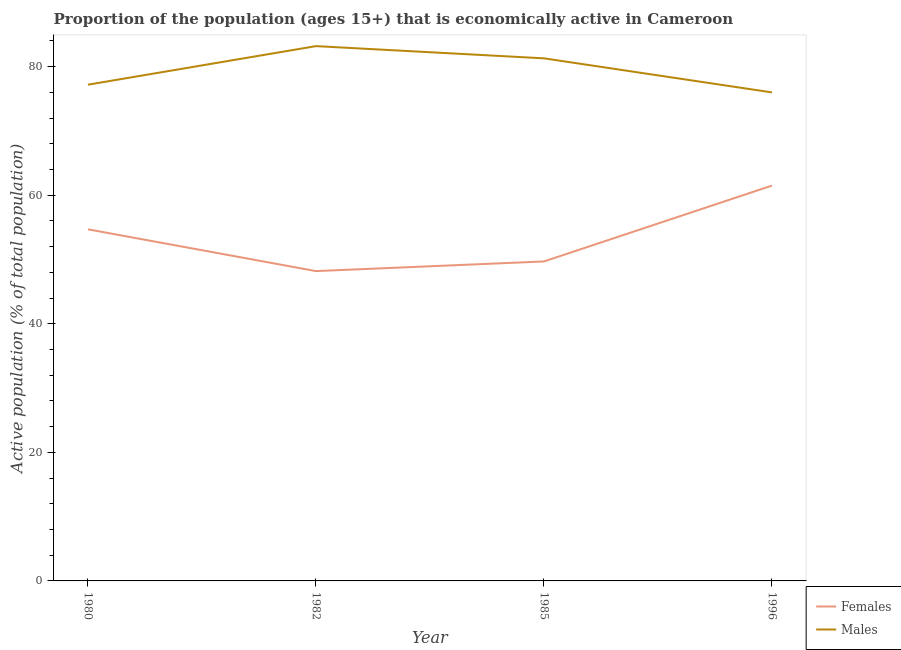Is the number of lines equal to the number of legend labels?
Provide a succinct answer. Yes. What is the percentage of economically active male population in 1985?
Ensure brevity in your answer.  81.3. Across all years, what is the maximum percentage of economically active male population?
Your response must be concise. 83.2. Across all years, what is the minimum percentage of economically active female population?
Make the answer very short. 48.2. In which year was the percentage of economically active female population minimum?
Keep it short and to the point. 1982. What is the total percentage of economically active female population in the graph?
Provide a succinct answer. 214.1. What is the difference between the percentage of economically active male population in 1980 and that in 1985?
Offer a terse response. -4.1. What is the difference between the percentage of economically active male population in 1996 and the percentage of economically active female population in 1982?
Make the answer very short. 27.8. What is the average percentage of economically active male population per year?
Provide a succinct answer. 79.42. In the year 1980, what is the difference between the percentage of economically active male population and percentage of economically active female population?
Provide a succinct answer. 22.5. What is the ratio of the percentage of economically active female population in 1985 to that in 1996?
Keep it short and to the point. 0.81. Is the percentage of economically active female population in 1985 less than that in 1996?
Your response must be concise. Yes. Is the difference between the percentage of economically active female population in 1980 and 1982 greater than the difference between the percentage of economically active male population in 1980 and 1982?
Make the answer very short. Yes. What is the difference between the highest and the second highest percentage of economically active female population?
Offer a terse response. 6.8. What is the difference between the highest and the lowest percentage of economically active female population?
Keep it short and to the point. 13.3. Is the sum of the percentage of economically active male population in 1982 and 1985 greater than the maximum percentage of economically active female population across all years?
Your answer should be compact. Yes. Does the percentage of economically active female population monotonically increase over the years?
Ensure brevity in your answer.  No. Is the percentage of economically active male population strictly less than the percentage of economically active female population over the years?
Provide a succinct answer. No. Does the graph contain any zero values?
Provide a short and direct response. No. How many legend labels are there?
Offer a terse response. 2. How are the legend labels stacked?
Ensure brevity in your answer.  Vertical. What is the title of the graph?
Provide a short and direct response. Proportion of the population (ages 15+) that is economically active in Cameroon. Does "Infant" appear as one of the legend labels in the graph?
Provide a succinct answer. No. What is the label or title of the Y-axis?
Give a very brief answer. Active population (% of total population). What is the Active population (% of total population) in Females in 1980?
Offer a terse response. 54.7. What is the Active population (% of total population) in Males in 1980?
Ensure brevity in your answer.  77.2. What is the Active population (% of total population) of Females in 1982?
Ensure brevity in your answer.  48.2. What is the Active population (% of total population) in Males in 1982?
Make the answer very short. 83.2. What is the Active population (% of total population) of Females in 1985?
Ensure brevity in your answer.  49.7. What is the Active population (% of total population) of Males in 1985?
Your response must be concise. 81.3. What is the Active population (% of total population) of Females in 1996?
Ensure brevity in your answer.  61.5. What is the Active population (% of total population) in Males in 1996?
Your answer should be very brief. 76. Across all years, what is the maximum Active population (% of total population) of Females?
Keep it short and to the point. 61.5. Across all years, what is the maximum Active population (% of total population) of Males?
Keep it short and to the point. 83.2. Across all years, what is the minimum Active population (% of total population) in Females?
Ensure brevity in your answer.  48.2. Across all years, what is the minimum Active population (% of total population) of Males?
Your response must be concise. 76. What is the total Active population (% of total population) of Females in the graph?
Your response must be concise. 214.1. What is the total Active population (% of total population) of Males in the graph?
Your answer should be very brief. 317.7. What is the difference between the Active population (% of total population) in Females in 1980 and that in 1982?
Offer a terse response. 6.5. What is the difference between the Active population (% of total population) of Males in 1980 and that in 1982?
Keep it short and to the point. -6. What is the difference between the Active population (% of total population) of Females in 1980 and that in 1985?
Keep it short and to the point. 5. What is the difference between the Active population (% of total population) of Males in 1980 and that in 1996?
Offer a terse response. 1.2. What is the difference between the Active population (% of total population) of Males in 1982 and that in 1985?
Give a very brief answer. 1.9. What is the difference between the Active population (% of total population) of Males in 1982 and that in 1996?
Make the answer very short. 7.2. What is the difference between the Active population (% of total population) of Females in 1980 and the Active population (% of total population) of Males in 1982?
Your answer should be compact. -28.5. What is the difference between the Active population (% of total population) of Females in 1980 and the Active population (% of total population) of Males in 1985?
Ensure brevity in your answer.  -26.6. What is the difference between the Active population (% of total population) in Females in 1980 and the Active population (% of total population) in Males in 1996?
Provide a succinct answer. -21.3. What is the difference between the Active population (% of total population) of Females in 1982 and the Active population (% of total population) of Males in 1985?
Your answer should be very brief. -33.1. What is the difference between the Active population (% of total population) of Females in 1982 and the Active population (% of total population) of Males in 1996?
Make the answer very short. -27.8. What is the difference between the Active population (% of total population) of Females in 1985 and the Active population (% of total population) of Males in 1996?
Provide a short and direct response. -26.3. What is the average Active population (% of total population) of Females per year?
Offer a terse response. 53.52. What is the average Active population (% of total population) of Males per year?
Ensure brevity in your answer.  79.42. In the year 1980, what is the difference between the Active population (% of total population) of Females and Active population (% of total population) of Males?
Provide a short and direct response. -22.5. In the year 1982, what is the difference between the Active population (% of total population) in Females and Active population (% of total population) in Males?
Your answer should be very brief. -35. In the year 1985, what is the difference between the Active population (% of total population) in Females and Active population (% of total population) in Males?
Your answer should be compact. -31.6. In the year 1996, what is the difference between the Active population (% of total population) of Females and Active population (% of total population) of Males?
Your response must be concise. -14.5. What is the ratio of the Active population (% of total population) of Females in 1980 to that in 1982?
Your answer should be very brief. 1.13. What is the ratio of the Active population (% of total population) of Males in 1980 to that in 1982?
Offer a terse response. 0.93. What is the ratio of the Active population (% of total population) in Females in 1980 to that in 1985?
Your response must be concise. 1.1. What is the ratio of the Active population (% of total population) in Males in 1980 to that in 1985?
Your answer should be compact. 0.95. What is the ratio of the Active population (% of total population) of Females in 1980 to that in 1996?
Your answer should be very brief. 0.89. What is the ratio of the Active population (% of total population) in Males in 1980 to that in 1996?
Make the answer very short. 1.02. What is the ratio of the Active population (% of total population) in Females in 1982 to that in 1985?
Make the answer very short. 0.97. What is the ratio of the Active population (% of total population) in Males in 1982 to that in 1985?
Your answer should be compact. 1.02. What is the ratio of the Active population (% of total population) in Females in 1982 to that in 1996?
Make the answer very short. 0.78. What is the ratio of the Active population (% of total population) of Males in 1982 to that in 1996?
Give a very brief answer. 1.09. What is the ratio of the Active population (% of total population) in Females in 1985 to that in 1996?
Your response must be concise. 0.81. What is the ratio of the Active population (% of total population) of Males in 1985 to that in 1996?
Your answer should be very brief. 1.07. What is the difference between the highest and the second highest Active population (% of total population) of Females?
Make the answer very short. 6.8. What is the difference between the highest and the second highest Active population (% of total population) of Males?
Your answer should be very brief. 1.9. What is the difference between the highest and the lowest Active population (% of total population) in Females?
Give a very brief answer. 13.3. What is the difference between the highest and the lowest Active population (% of total population) of Males?
Give a very brief answer. 7.2. 